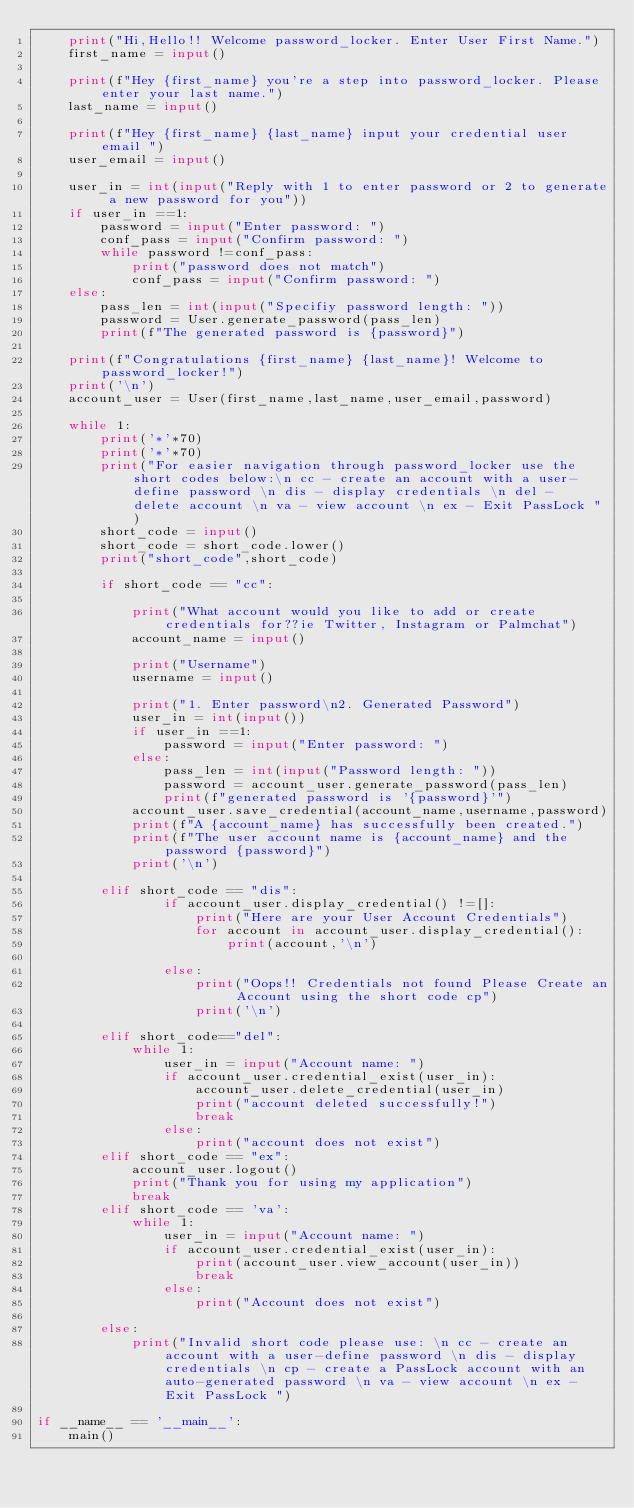<code> <loc_0><loc_0><loc_500><loc_500><_Python_>    print("Hi,Hello!! Welcome password_locker. Enter User First Name.")
    first_name = input()

    print(f"Hey {first_name} you're a step into password_locker. Please enter your last name.")
    last_name = input()

    print(f"Hey {first_name} {last_name} input your credential user email ")
    user_email = input()

    user_in = int(input("Reply with 1 to enter password or 2 to generate a new password for you"))
    if user_in ==1:
        password = input("Enter password: ")
        conf_pass = input("Confirm password: ")
        while password !=conf_pass:
            print("password does not match")
            conf_pass = input("Confirm password: ")
    else:
        pass_len = int(input("Specifiy password length: "))
        password = User.generate_password(pass_len)
        print(f"The generated password is {password}")

    print(f"Congratulations {first_name} {last_name}! Welcome to password_locker!")
    print('\n')
    account_user = User(first_name,last_name,user_email,password)

    while 1:
        print('*'*70)
        print('*'*70)
        print("For easier navigation through password_locker use the short codes below:\n cc - create an account with a user-define password \n dis - display credentials \n del - delete account \n va - view account \n ex - Exit PassLock ")
        short_code = input()
        short_code = short_code.lower()
        print("short_code",short_code)

        if short_code == "cc":
            
            print("What account would you like to add or create credentials for??ie Twitter, Instagram or Palmchat")
            account_name = input()

            print("Username")
            username = input()

            print("1. Enter password\n2. Generated Password")
            user_in = int(input())
            if user_in ==1:
                password = input("Enter password: ")
            else:
                pass_len = int(input("Password length: "))
                password = account_user.generate_password(pass_len)
                print(f"generated password is '{password}'")
            account_user.save_credential(account_name,username,password)           
            print(f"A {account_name} has successfully been created.")
            print(f"The user account name is {account_name} and the password {password}")
            print('\n')

        elif short_code == "dis":
                if account_user.display_credential() !=[]:
                    print("Here are your User Account Credentials")
                    for account in account_user.display_credential():
                        print(account,'\n')
                
                else:
                    print("Oops!! Credentials not found Please Create an Account using the short code cp")
                    print('\n')

        elif short_code=="del":
            while 1:
                user_in = input("Account name: ")
                if account_user.credential_exist(user_in):
                    account_user.delete_credential(user_in)
                    print("account deleted successfully!")
                    break
                else:
                    print("account does not exist")
        elif short_code == "ex":
            account_user.logout()
            print("Thank you for using my application")
            break
        elif short_code == 'va':
            while 1:
                user_in = input("Account name: ")
                if account_user.credential_exist(user_in):
                    print(account_user.view_account(user_in))
                    break
                else:
                    print("Account does not exist")

        else:
            print("Invalid short code please use: \n cc - create an account with a user-define password \n dis - display credentials \n cp - create a PassLock account with an auto-generated password \n va - view account \n ex - Exit PassLock ")

if __name__ == '__main__':
    main()</code> 